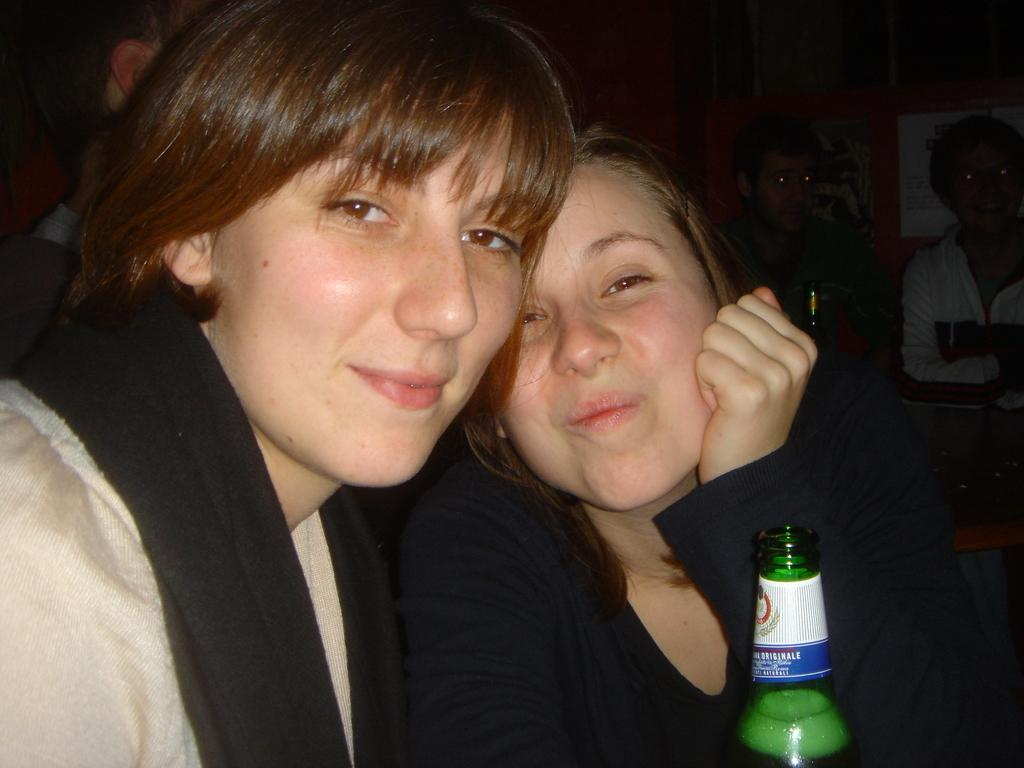How many people are in the image? There are two women in the image. What are the women doing in the image? The women are seated and smiling. What is in front of the women? There is a bottle in front of the women. What type of test can be seen being conducted in the image? There is no test being conducted in the image; it features two women who are seated and smiling. What word is written on the cart in the image? There is no cart or word present in the image. 